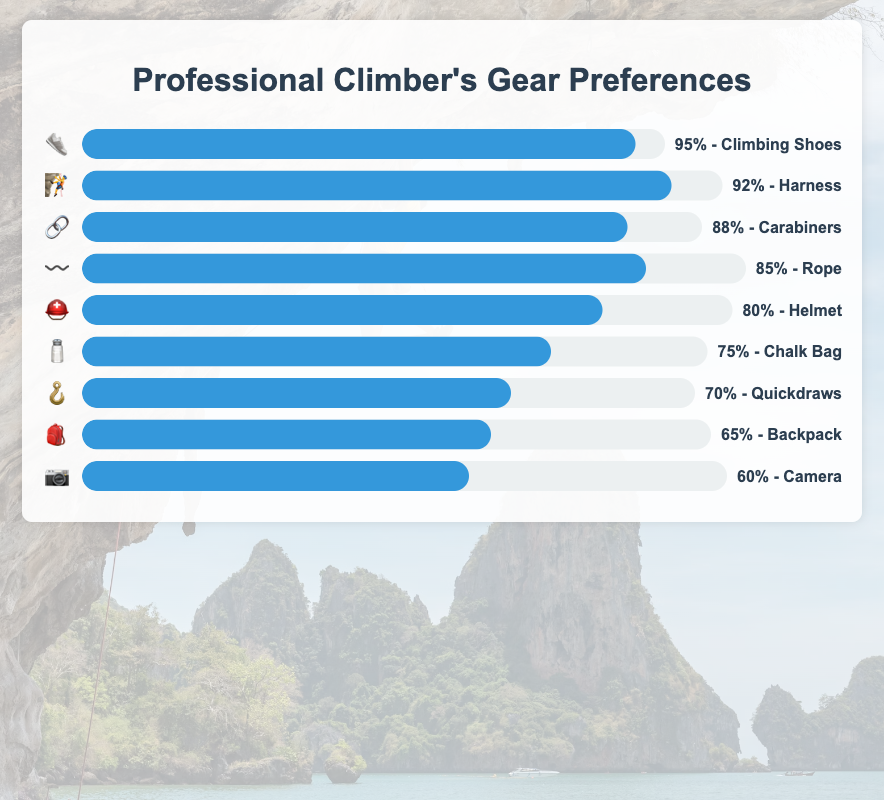Which gear has the highest preference among professional climbers? The gear with the highest percentage in the chart represents the most preferred gear. In this case, it's the "Climbing Shoes" with 95% preference.
Answer: Climbing Shoes Which gear has the lowest preference? The gear with the lowest percentage in the chart represents the least preferred gear. "Camera" has the lowest preference at 60%.
Answer: Camera What is the combined preference percentage of Carabiners and Helmet? Add the preferences of Carabiners (88%) and Helmet (80%) together: 88% + 80% = 168%
Answer: 168% How much higher is the preference for Harness compared to Quickdraws? Subtract the preference for Quickdraws (70%) from the preference for Harness (92%): 92% - 70% = 22%
Answer: 22% List three gears with preferences above 80%. Identify and list gears that have preference percentages greater than 80%. Climbing Shoes (95%), Harness (92%), Carabiners (88%), and Rope (85%). Pick three from this list.
Answer: Climbing Shoes, Harness, Carabiners What is the average preference percentage of all the listed gears? Calculate the average by summing all the preferences and dividing by the number of gears. (95+92+88+85+80+75+70+65+60) / 9 = 78.89%
Answer: 78.89% Which two gears have the closest preference percentages? Compare the differences between preference percentages of all gears and identify the smallest difference. Quickdraws (70%) and Backpack (65%) have a difference of 5%.
Answer: Quickdraws and Backpack What is the preference percentage difference between the most preferred and the least preferred gear? Subtract the preference of the least preferred gear (Camera at 60%) from the most preferred gear (Climbing Shoes at 95%): 95% - 60% = 35%
Answer: 35% Is the preference for Helmet higher or lower than the average preference percentage? Calculate the average preference percentage (78.89%) and compare it with Helmet's preference (80%). Since 80% is higher than 78.89%, Helmet's preference is higher.
Answer: Higher What percentage of climbers prefer Chalk Bag over Quickdraws? The percentage is the difference between preferences of Chalk Bag (75%) and Quickdraws (70%): 75% - 70% = 5%
Answer: 5% 